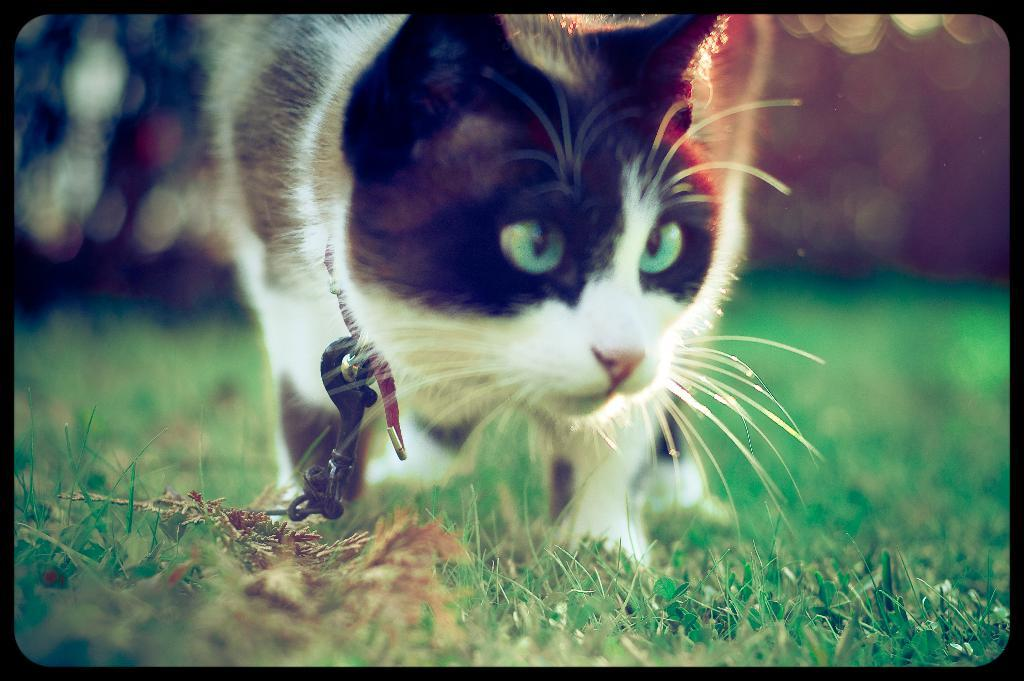What type of animal is in the image? There is a cat in the image. Where is the cat located? The cat is on the ground. What type of surface is the cat on? There is grass on the ground. What type of ring is the cat wearing in the image? There is no ring present on the cat in the image. What type of writing can be seen on the cat's fur in the image? There is no writing present on the cat's fur in the image. 